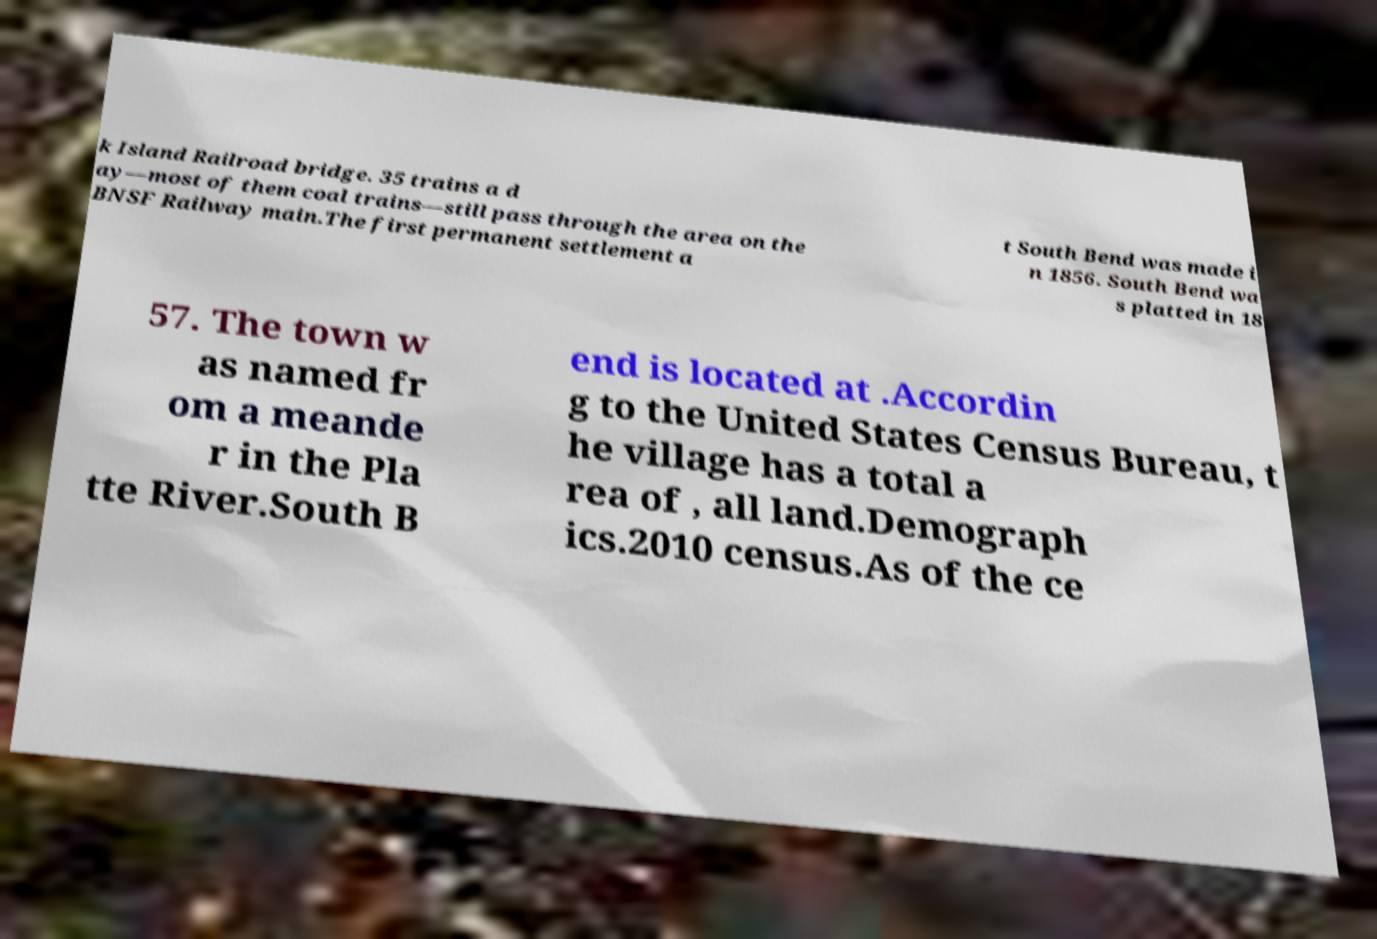For documentation purposes, I need the text within this image transcribed. Could you provide that? k Island Railroad bridge. 35 trains a d ay—most of them coal trains—still pass through the area on the BNSF Railway main.The first permanent settlement a t South Bend was made i n 1856. South Bend wa s platted in 18 57. The town w as named fr om a meande r in the Pla tte River.South B end is located at .Accordin g to the United States Census Bureau, t he village has a total a rea of , all land.Demograph ics.2010 census.As of the ce 